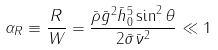<formula> <loc_0><loc_0><loc_500><loc_500>\alpha _ { R } \equiv \frac { R } { W } = \frac { \bar { \rho } \bar { g } ^ { 2 } \bar { h } _ { 0 } ^ { 5 } \sin ^ { 2 } \theta } { 2 \bar { \sigma } \bar { \nu } ^ { 2 } } \ll 1</formula> 